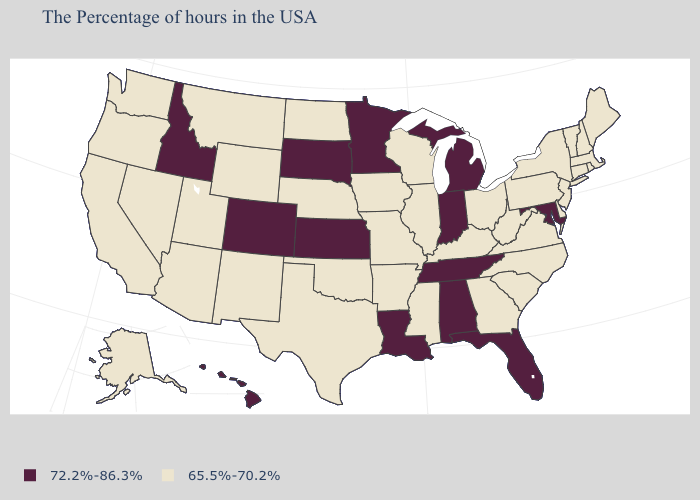Does the first symbol in the legend represent the smallest category?
Write a very short answer. No. Does Kentucky have a lower value than Colorado?
Give a very brief answer. Yes. Does Maryland have the highest value in the USA?
Short answer required. Yes. Name the states that have a value in the range 65.5%-70.2%?
Give a very brief answer. Maine, Massachusetts, Rhode Island, New Hampshire, Vermont, Connecticut, New York, New Jersey, Delaware, Pennsylvania, Virginia, North Carolina, South Carolina, West Virginia, Ohio, Georgia, Kentucky, Wisconsin, Illinois, Mississippi, Missouri, Arkansas, Iowa, Nebraska, Oklahoma, Texas, North Dakota, Wyoming, New Mexico, Utah, Montana, Arizona, Nevada, California, Washington, Oregon, Alaska. What is the lowest value in states that border Pennsylvania?
Concise answer only. 65.5%-70.2%. Does Montana have a lower value than Michigan?
Write a very short answer. Yes. Among the states that border Virginia , which have the lowest value?
Answer briefly. North Carolina, West Virginia, Kentucky. Name the states that have a value in the range 72.2%-86.3%?
Write a very short answer. Maryland, Florida, Michigan, Indiana, Alabama, Tennessee, Louisiana, Minnesota, Kansas, South Dakota, Colorado, Idaho, Hawaii. Does the first symbol in the legend represent the smallest category?
Answer briefly. No. Which states have the lowest value in the MidWest?
Keep it brief. Ohio, Wisconsin, Illinois, Missouri, Iowa, Nebraska, North Dakota. What is the highest value in states that border New Hampshire?
Keep it brief. 65.5%-70.2%. Name the states that have a value in the range 72.2%-86.3%?
Write a very short answer. Maryland, Florida, Michigan, Indiana, Alabama, Tennessee, Louisiana, Minnesota, Kansas, South Dakota, Colorado, Idaho, Hawaii. What is the highest value in the Northeast ?
Short answer required. 65.5%-70.2%. What is the value of Pennsylvania?
Keep it brief. 65.5%-70.2%. What is the value of Missouri?
Give a very brief answer. 65.5%-70.2%. 